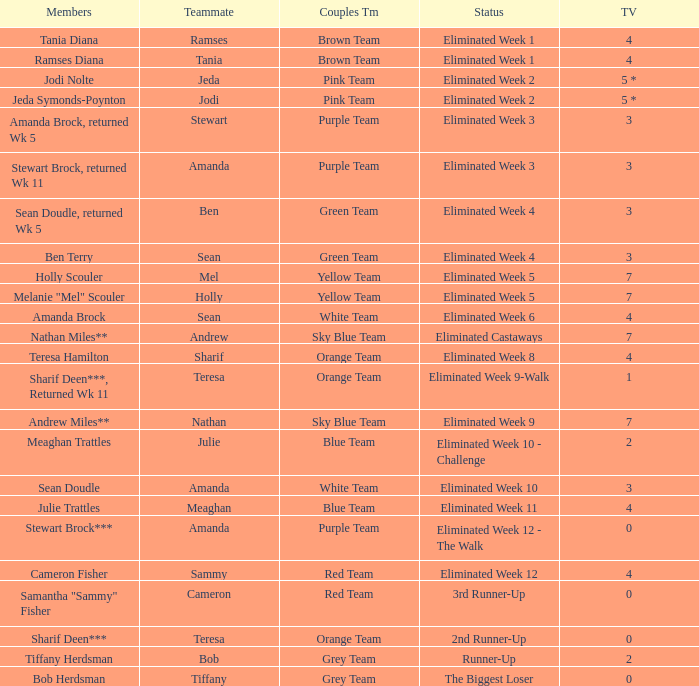Who had 0 total votes in the purple team? Eliminated Week 12 - The Walk. 